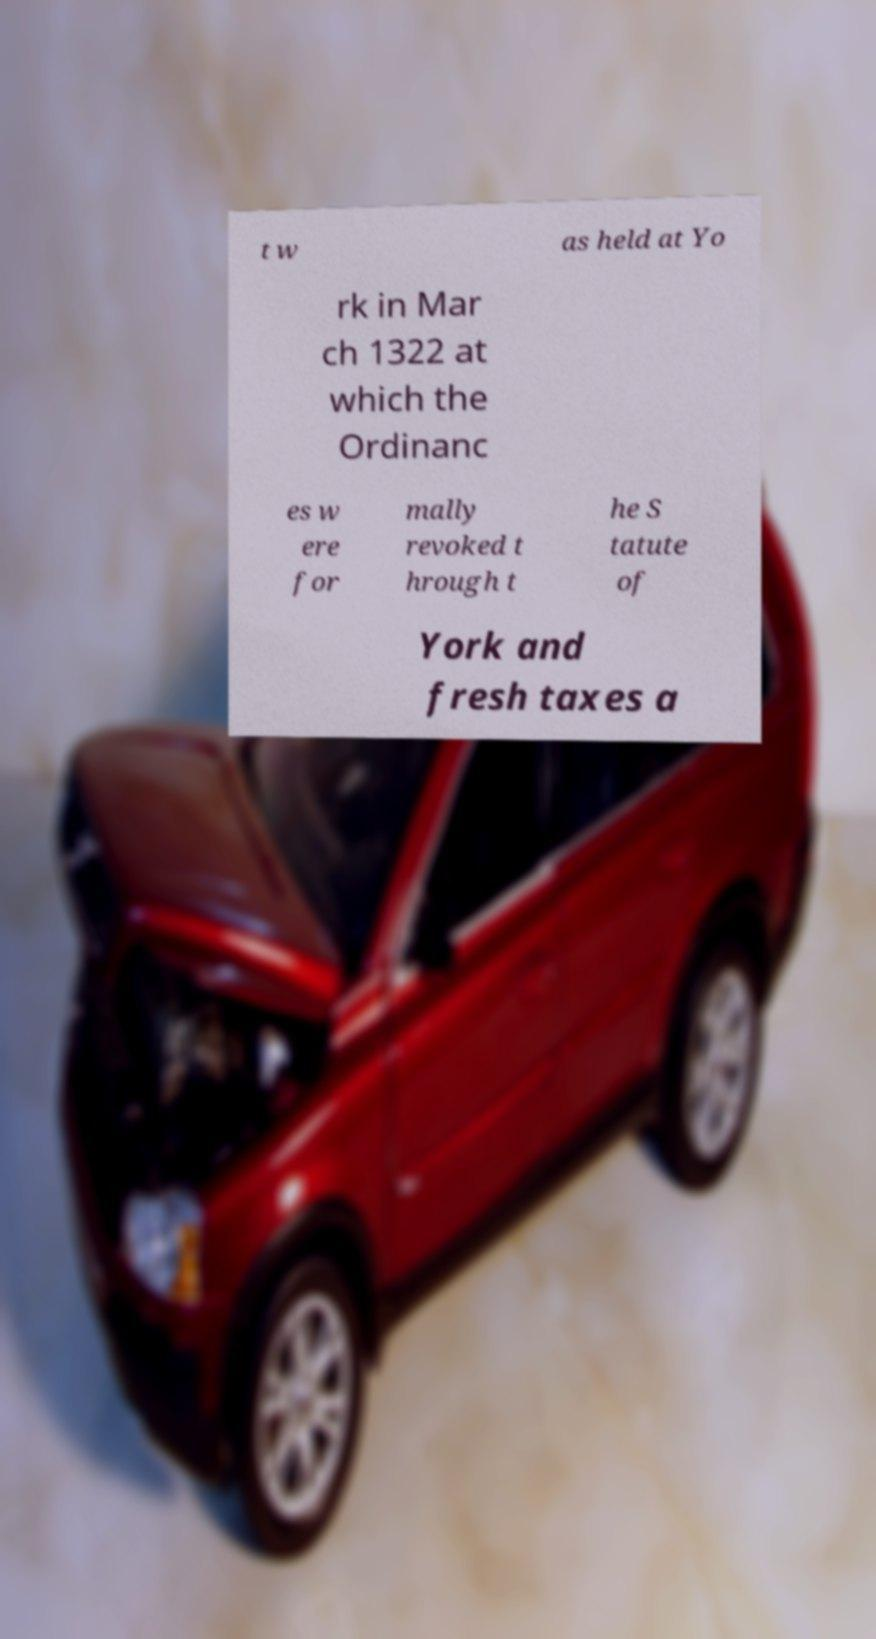Please identify and transcribe the text found in this image. t w as held at Yo rk in Mar ch 1322 at which the Ordinanc es w ere for mally revoked t hrough t he S tatute of York and fresh taxes a 